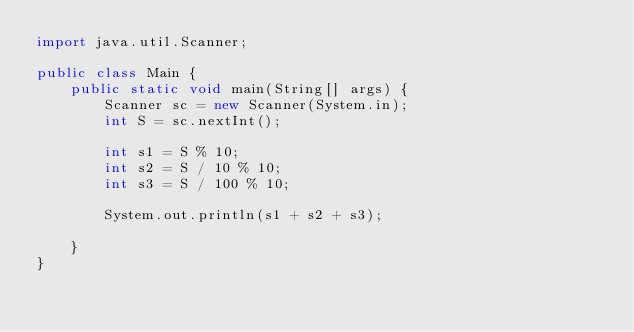<code> <loc_0><loc_0><loc_500><loc_500><_Java_>import java.util.Scanner;

public class Main {
	public static void main(String[] args) {
		Scanner sc = new Scanner(System.in);
		int S = sc.nextInt();
		
		int s1 = S % 10;
		int s2 = S / 10 % 10;
		int s3 = S / 100 % 10;
		
		System.out.println(s1 + s2 + s3);
		
	}
}
</code> 